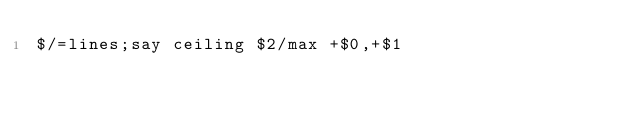<code> <loc_0><loc_0><loc_500><loc_500><_Perl_>$/=lines;say ceiling $2/max +$0,+$1</code> 